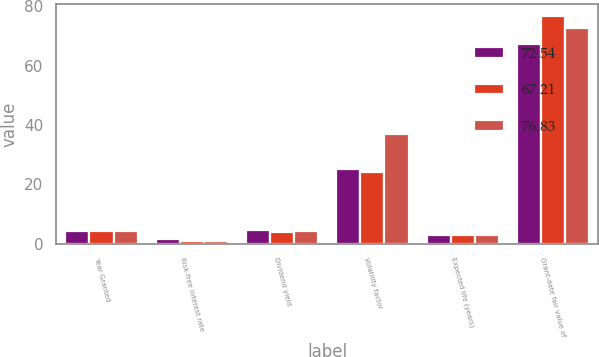<chart> <loc_0><loc_0><loc_500><loc_500><stacked_bar_chart><ecel><fcel>Year Granted<fcel>Risk-free interest rate<fcel>Dividend yield<fcel>Volatility factor<fcel>Expected life (years)<fcel>Grant-date fair value of<nl><fcel>72.54<fcel>4.1<fcel>1.5<fcel>4.5<fcel>25<fcel>3<fcel>67.21<nl><fcel>67.21<fcel>4.1<fcel>0.8<fcel>3.9<fcel>24<fcel>3<fcel>76.83<nl><fcel>76.83<fcel>4.1<fcel>0.9<fcel>4.1<fcel>37<fcel>3<fcel>72.54<nl></chart> 